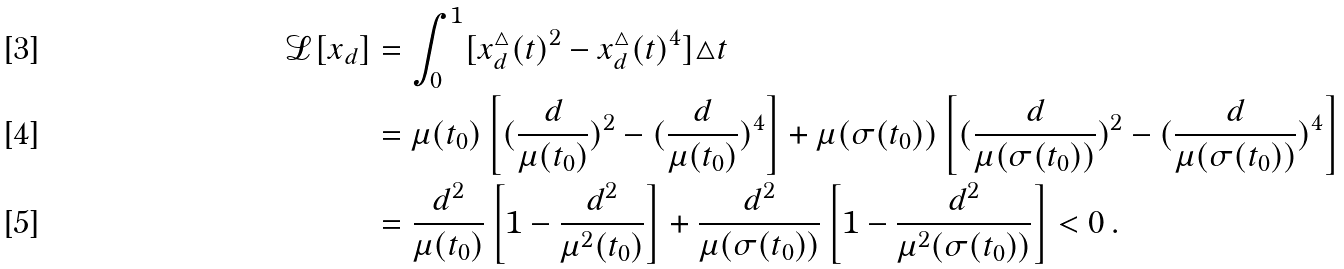Convert formula to latex. <formula><loc_0><loc_0><loc_500><loc_500>\mathcal { L } [ x _ { d } ] & = \int _ { 0 } ^ { 1 } [ x _ { d } ^ { \triangle } ( t ) ^ { 2 } - x ^ { \triangle } _ { d } ( t ) ^ { 4 } ] \triangle t \\ & = \mu ( t _ { 0 } ) \left [ ( \frac { d } { \mu ( t _ { 0 } ) } ) ^ { 2 } - ( \frac { d } { \mu ( t _ { 0 } ) } ) ^ { 4 } \right ] + \mu ( \sigma ( t _ { 0 } ) ) \left [ ( \frac { d } { \mu ( \sigma ( t _ { 0 } ) ) } ) ^ { 2 } - ( \frac { d } { \mu ( \sigma ( t _ { 0 } ) ) } ) ^ { 4 } \right ] \\ & = \frac { d ^ { 2 } } { \mu ( t _ { 0 } ) } \left [ 1 - \frac { d ^ { 2 } } { \mu ^ { 2 } ( t _ { 0 } ) } \right ] + \frac { d ^ { 2 } } { \mu ( \sigma ( t _ { 0 } ) ) } \left [ 1 - \frac { d ^ { 2 } } { \mu ^ { 2 } ( \sigma ( t _ { 0 } ) ) } \right ] < 0 \, .</formula> 